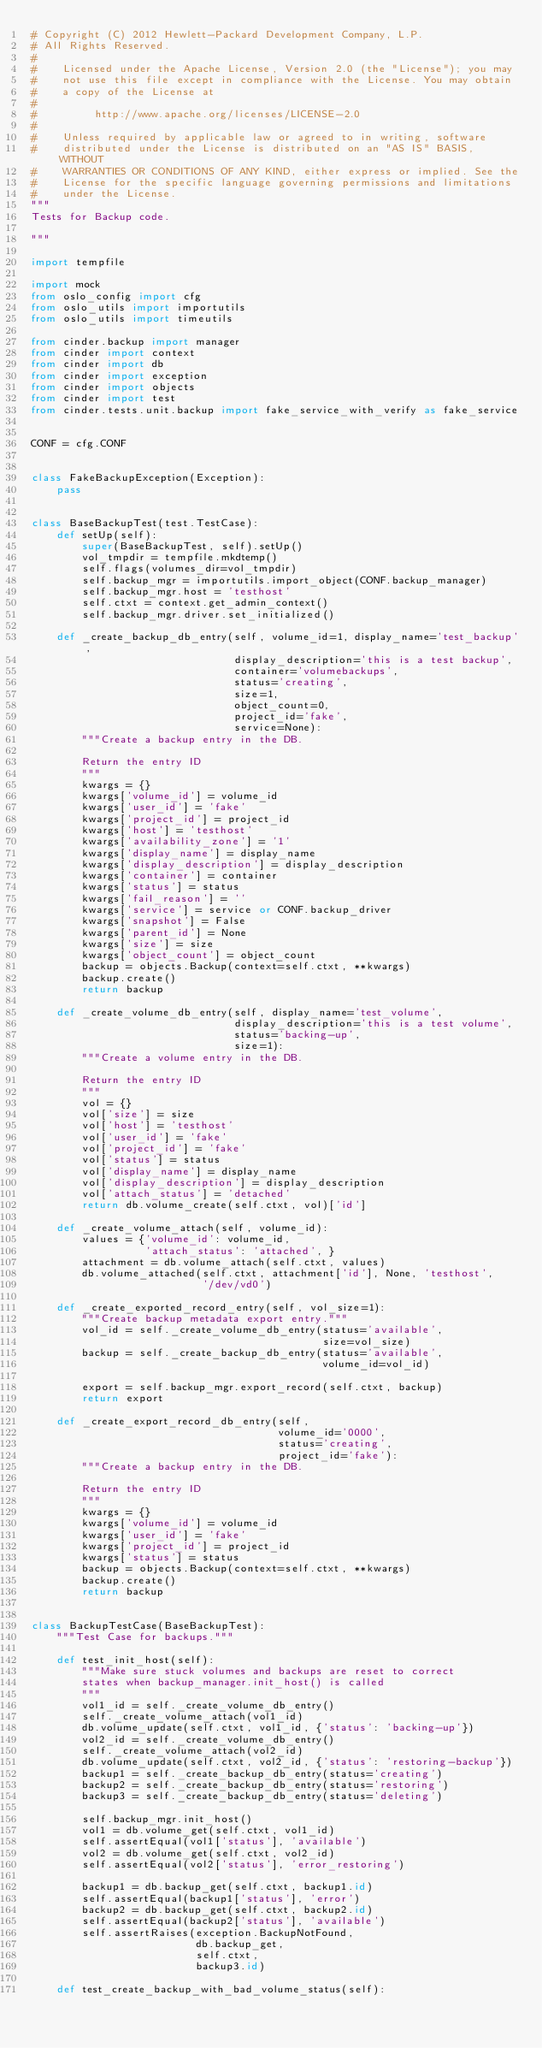Convert code to text. <code><loc_0><loc_0><loc_500><loc_500><_Python_># Copyright (C) 2012 Hewlett-Packard Development Company, L.P.
# All Rights Reserved.
#
#    Licensed under the Apache License, Version 2.0 (the "License"); you may
#    not use this file except in compliance with the License. You may obtain
#    a copy of the License at
#
#         http://www.apache.org/licenses/LICENSE-2.0
#
#    Unless required by applicable law or agreed to in writing, software
#    distributed under the License is distributed on an "AS IS" BASIS, WITHOUT
#    WARRANTIES OR CONDITIONS OF ANY KIND, either express or implied. See the
#    License for the specific language governing permissions and limitations
#    under the License.
"""
Tests for Backup code.

"""

import tempfile

import mock
from oslo_config import cfg
from oslo_utils import importutils
from oslo_utils import timeutils

from cinder.backup import manager
from cinder import context
from cinder import db
from cinder import exception
from cinder import objects
from cinder import test
from cinder.tests.unit.backup import fake_service_with_verify as fake_service


CONF = cfg.CONF


class FakeBackupException(Exception):
    pass


class BaseBackupTest(test.TestCase):
    def setUp(self):
        super(BaseBackupTest, self).setUp()
        vol_tmpdir = tempfile.mkdtemp()
        self.flags(volumes_dir=vol_tmpdir)
        self.backup_mgr = importutils.import_object(CONF.backup_manager)
        self.backup_mgr.host = 'testhost'
        self.ctxt = context.get_admin_context()
        self.backup_mgr.driver.set_initialized()

    def _create_backup_db_entry(self, volume_id=1, display_name='test_backup',
                                display_description='this is a test backup',
                                container='volumebackups',
                                status='creating',
                                size=1,
                                object_count=0,
                                project_id='fake',
                                service=None):
        """Create a backup entry in the DB.

        Return the entry ID
        """
        kwargs = {}
        kwargs['volume_id'] = volume_id
        kwargs['user_id'] = 'fake'
        kwargs['project_id'] = project_id
        kwargs['host'] = 'testhost'
        kwargs['availability_zone'] = '1'
        kwargs['display_name'] = display_name
        kwargs['display_description'] = display_description
        kwargs['container'] = container
        kwargs['status'] = status
        kwargs['fail_reason'] = ''
        kwargs['service'] = service or CONF.backup_driver
        kwargs['snapshot'] = False
        kwargs['parent_id'] = None
        kwargs['size'] = size
        kwargs['object_count'] = object_count
        backup = objects.Backup(context=self.ctxt, **kwargs)
        backup.create()
        return backup

    def _create_volume_db_entry(self, display_name='test_volume',
                                display_description='this is a test volume',
                                status='backing-up',
                                size=1):
        """Create a volume entry in the DB.

        Return the entry ID
        """
        vol = {}
        vol['size'] = size
        vol['host'] = 'testhost'
        vol['user_id'] = 'fake'
        vol['project_id'] = 'fake'
        vol['status'] = status
        vol['display_name'] = display_name
        vol['display_description'] = display_description
        vol['attach_status'] = 'detached'
        return db.volume_create(self.ctxt, vol)['id']

    def _create_volume_attach(self, volume_id):
        values = {'volume_id': volume_id,
                  'attach_status': 'attached', }
        attachment = db.volume_attach(self.ctxt, values)
        db.volume_attached(self.ctxt, attachment['id'], None, 'testhost',
                           '/dev/vd0')

    def _create_exported_record_entry(self, vol_size=1):
        """Create backup metadata export entry."""
        vol_id = self._create_volume_db_entry(status='available',
                                              size=vol_size)
        backup = self._create_backup_db_entry(status='available',
                                              volume_id=vol_id)

        export = self.backup_mgr.export_record(self.ctxt, backup)
        return export

    def _create_export_record_db_entry(self,
                                       volume_id='0000',
                                       status='creating',
                                       project_id='fake'):
        """Create a backup entry in the DB.

        Return the entry ID
        """
        kwargs = {}
        kwargs['volume_id'] = volume_id
        kwargs['user_id'] = 'fake'
        kwargs['project_id'] = project_id
        kwargs['status'] = status
        backup = objects.Backup(context=self.ctxt, **kwargs)
        backup.create()
        return backup


class BackupTestCase(BaseBackupTest):
    """Test Case for backups."""

    def test_init_host(self):
        """Make sure stuck volumes and backups are reset to correct
        states when backup_manager.init_host() is called
        """
        vol1_id = self._create_volume_db_entry()
        self._create_volume_attach(vol1_id)
        db.volume_update(self.ctxt, vol1_id, {'status': 'backing-up'})
        vol2_id = self._create_volume_db_entry()
        self._create_volume_attach(vol2_id)
        db.volume_update(self.ctxt, vol2_id, {'status': 'restoring-backup'})
        backup1 = self._create_backup_db_entry(status='creating')
        backup2 = self._create_backup_db_entry(status='restoring')
        backup3 = self._create_backup_db_entry(status='deleting')

        self.backup_mgr.init_host()
        vol1 = db.volume_get(self.ctxt, vol1_id)
        self.assertEqual(vol1['status'], 'available')
        vol2 = db.volume_get(self.ctxt, vol2_id)
        self.assertEqual(vol2['status'], 'error_restoring')

        backup1 = db.backup_get(self.ctxt, backup1.id)
        self.assertEqual(backup1['status'], 'error')
        backup2 = db.backup_get(self.ctxt, backup2.id)
        self.assertEqual(backup2['status'], 'available')
        self.assertRaises(exception.BackupNotFound,
                          db.backup_get,
                          self.ctxt,
                          backup3.id)

    def test_create_backup_with_bad_volume_status(self):</code> 